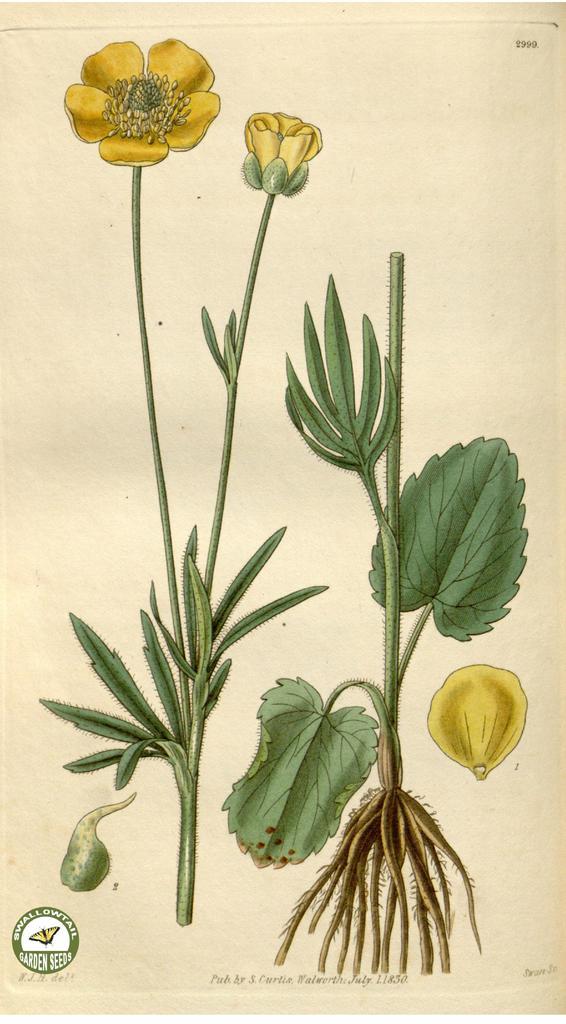Describe this image in one or two sentences. In this image we can see drawings of plants and flower on a paper. 